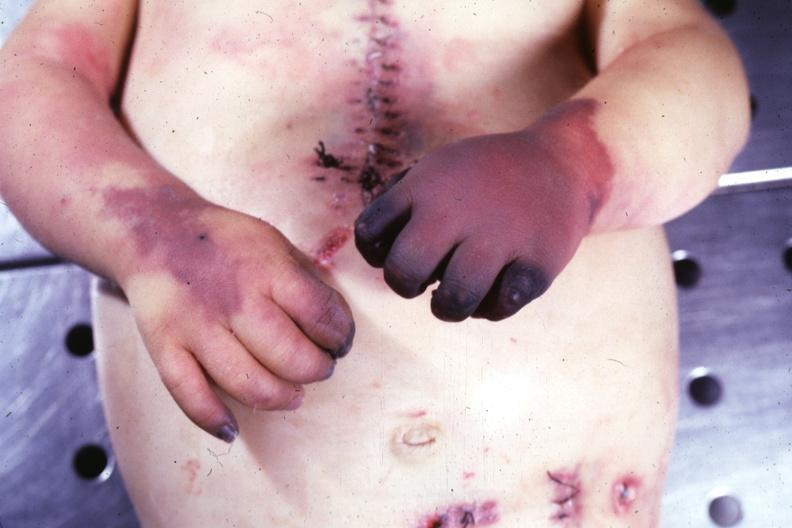does beckwith-wiedemann syndrome show gangrene both hands due to embolism case of av canal with downs syndrome?
Answer the question using a single word or phrase. No 